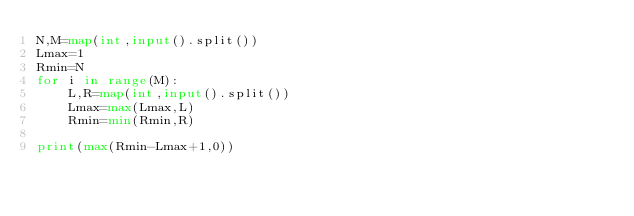<code> <loc_0><loc_0><loc_500><loc_500><_Python_>N,M=map(int,input().split())
Lmax=1
Rmin=N
for i in range(M):
    L,R=map(int,input().split())
    Lmax=max(Lmax,L)
    Rmin=min(Rmin,R)
    
print(max(Rmin-Lmax+1,0))</code> 